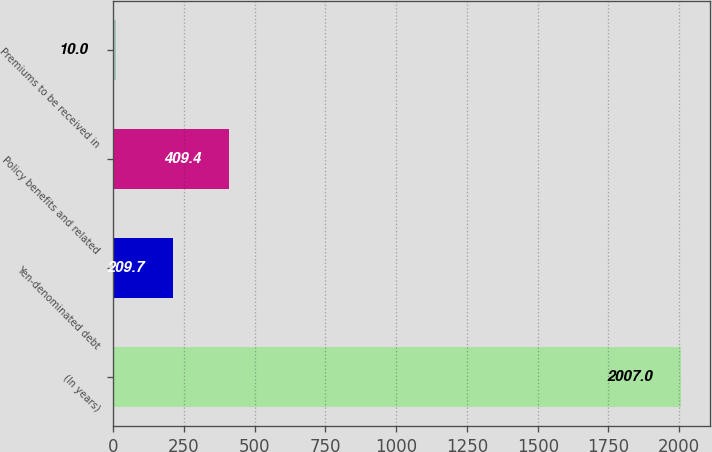Convert chart. <chart><loc_0><loc_0><loc_500><loc_500><bar_chart><fcel>(In years)<fcel>Yen-denominated debt<fcel>Policy benefits and related<fcel>Premiums to be received in<nl><fcel>2007<fcel>209.7<fcel>409.4<fcel>10<nl></chart> 